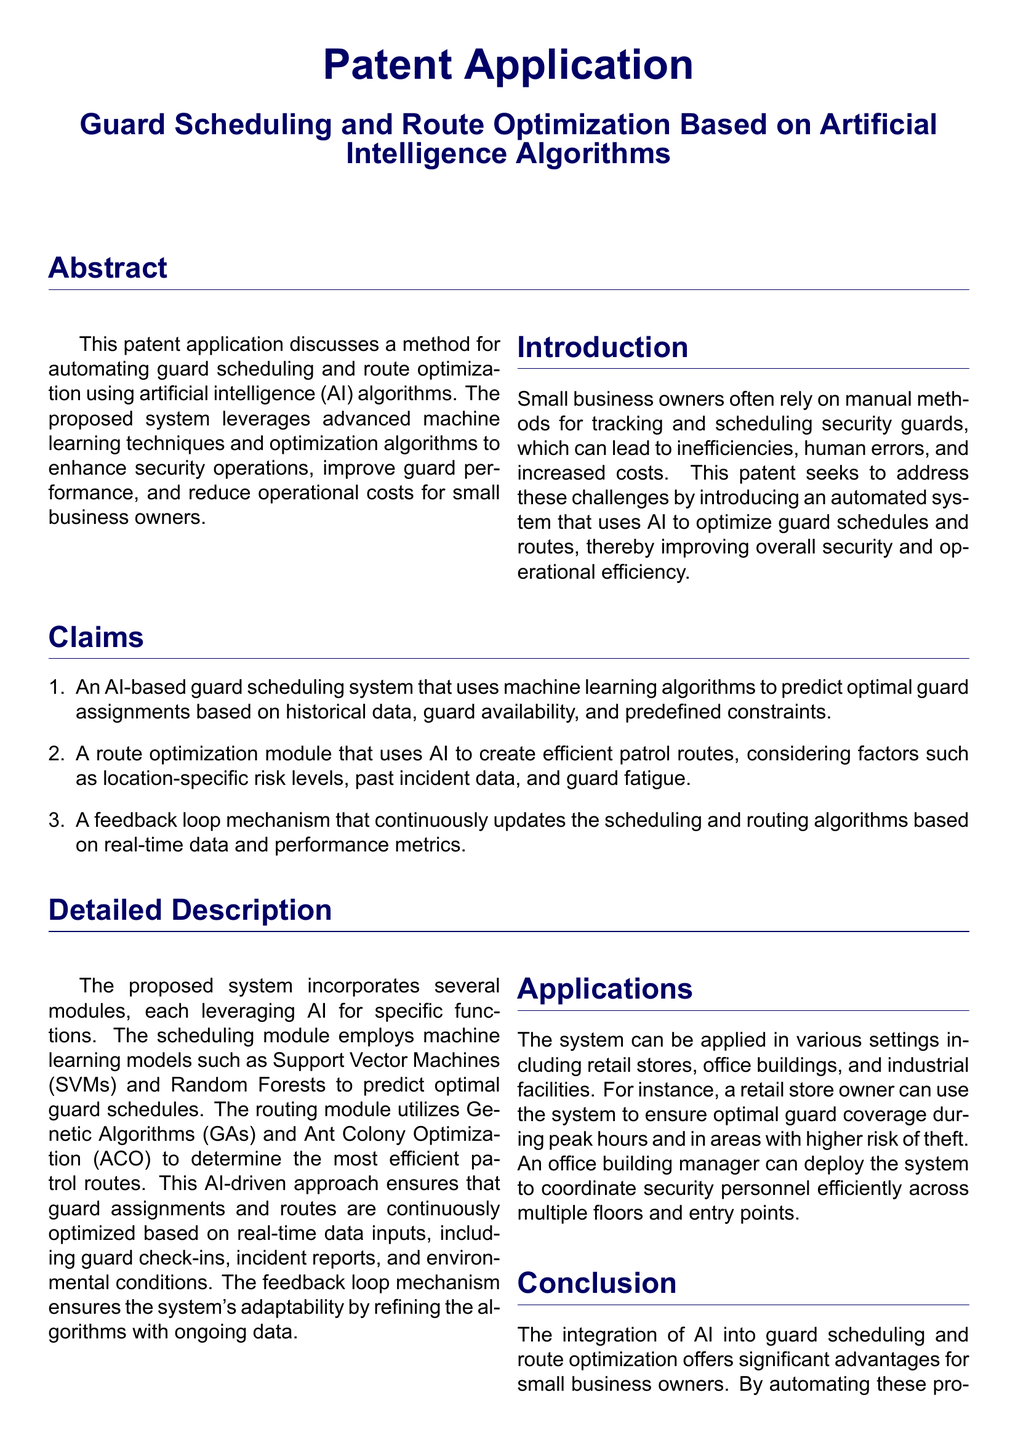What is the title of the patent application? The title of the patent application is stated prominently at the beginning of the document.
Answer: Guard Scheduling and Route Optimization Based on Artificial Intelligence Algorithms What is the main problem addressed by this patent application? The primary challenge that the patent seeks to address is detailed in the introduction section.
Answer: Inefficiencies in manual methods for tracking and scheduling security guards Which technology is used for predicting optimal guard assignments? The specific method for predicting guard assignments is mentioned in the claims section.
Answer: Machine learning algorithms What optimization algorithms are mentioned for route creation? The detailed description specifies the algorithms utilized for route optimization.
Answer: Genetic Algorithms and Ant Colony Optimization How many claims are made in the patent application? The total number of claims is indicated in the claims section.
Answer: Three In which settings can the system be applied? The applications of the system are outlined in the relevant section of the document.
Answer: Retail stores, office buildings, industrial facilities What is included in the feedback loop mechanism? The feedback loop mechanism is described in the detailed description, indicating what it entails.
Answer: Updates the scheduling and routing algorithms based on real-time data and performance metrics Who are the authors of the reference book mentioned? The references list attributes a significant artificial intelligence book to specific authors.
Answer: Stuart Russell and Peter Norvig What year was "Genetic Algorithms in Search, Optimization, and Machine Learning" published? The publication year for the reference book is clearly stated in the references section.
Answer: 1989 